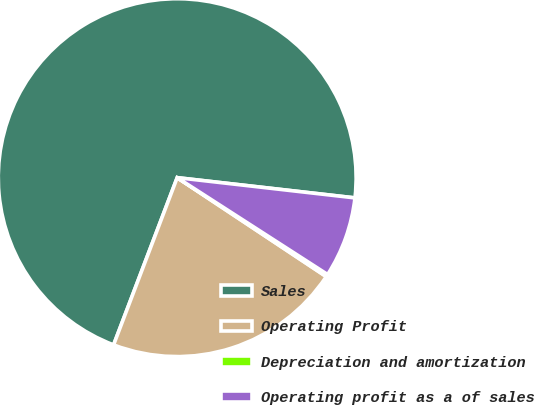Convert chart. <chart><loc_0><loc_0><loc_500><loc_500><pie_chart><fcel>Sales<fcel>Operating Profit<fcel>Depreciation and amortization<fcel>Operating profit as a of sales<nl><fcel>71.02%<fcel>21.46%<fcel>0.22%<fcel>7.3%<nl></chart> 